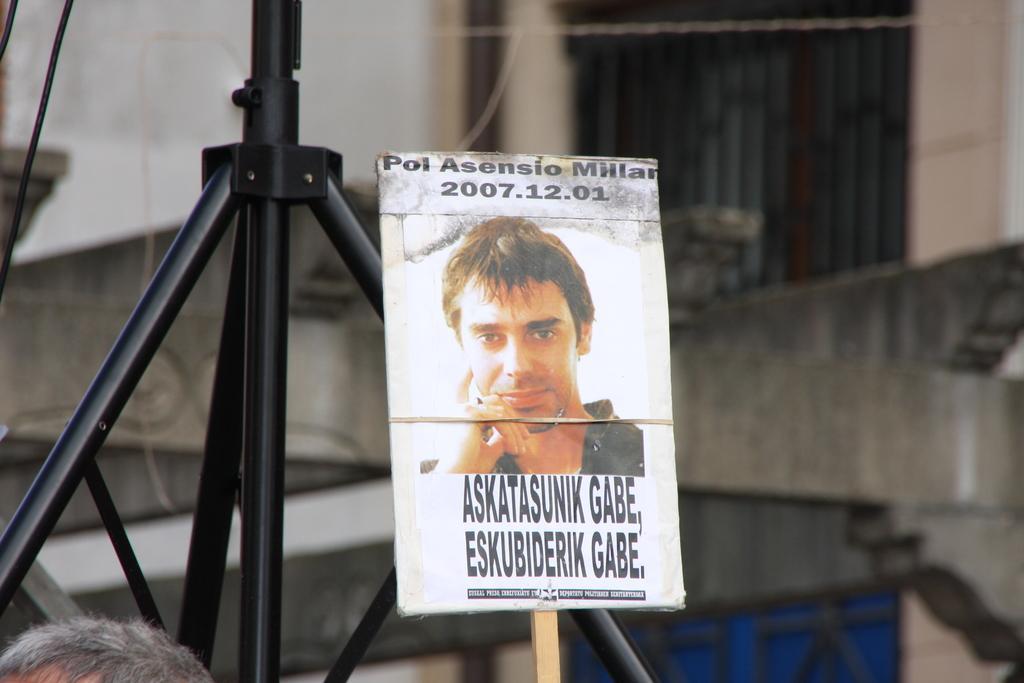How would you summarize this image in a sentence or two? It is a photograph which is pasted on the placard. 